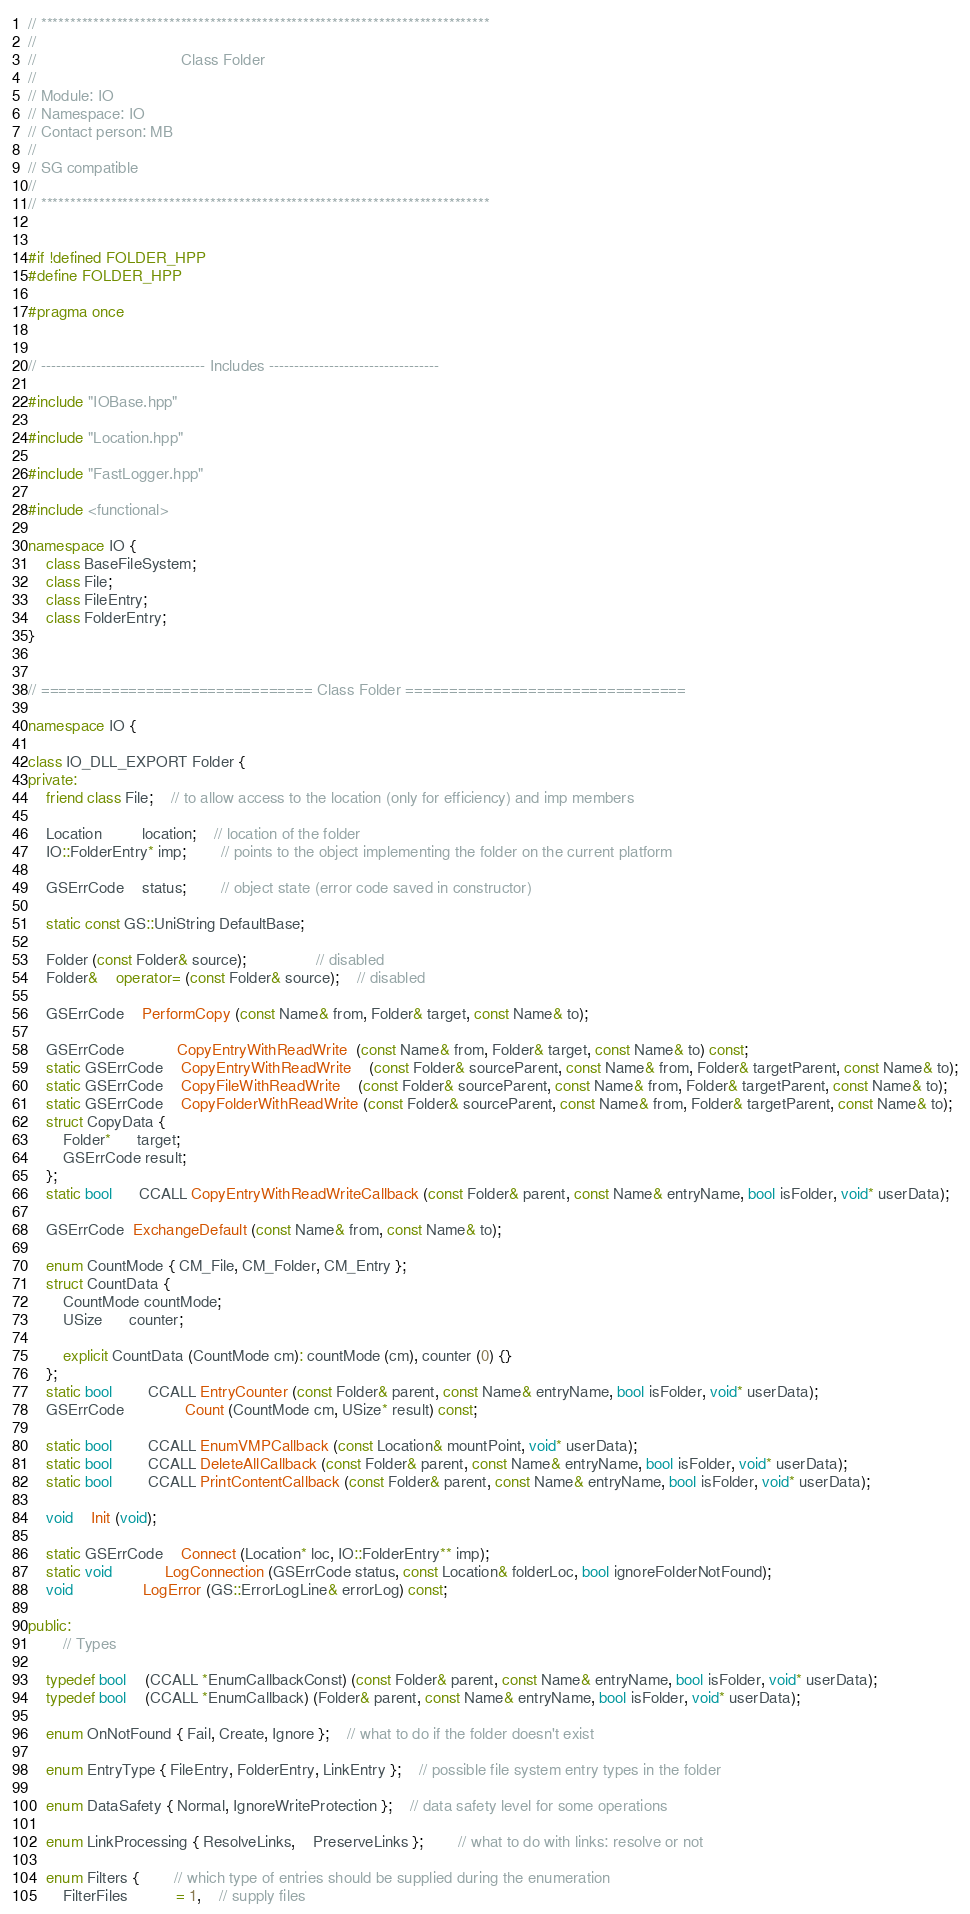Convert code to text. <code><loc_0><loc_0><loc_500><loc_500><_C++_>
// *****************************************************************************
//
//                                 Class Folder
//
// Module: IO
// Namespace: IO
// Contact person: MB
//
// SG compatible
//
// *****************************************************************************


#if !defined FOLDER_HPP
#define FOLDER_HPP

#pragma once


// --------------------------------- Includes ----------------------------------

#include "IOBase.hpp"

#include "Location.hpp"

#include "FastLogger.hpp"

#include <functional>

namespace IO {
	class BaseFileSystem;
	class File;
	class FileEntry;
	class FolderEntry;
}


// =============================== Class Folder ================================

namespace IO {

class IO_DLL_EXPORT Folder {
private:
	friend class File;	// to allow access to the location (only for efficiency) and imp members

	Location		 location;	// location of the folder
	IO::FolderEntry* imp;		// points to the object implementing the folder on the current platform

	GSErrCode	status;		// object state (error code saved in constructor)

	static const GS::UniString DefaultBase;

	Folder (const Folder& source);				// disabled
	Folder&	operator= (const Folder& source);	// disabled

	GSErrCode	PerformCopy (const Name& from, Folder& target, const Name& to);

	GSErrCode			CopyEntryWithReadWrite  (const Name& from, Folder& target, const Name& to) const;
	static GSErrCode	CopyEntryWithReadWrite	(const Folder& sourceParent, const Name& from, Folder& targetParent, const Name& to);
	static GSErrCode	CopyFileWithReadWrite	(const Folder& sourceParent, const Name& from, Folder& targetParent, const Name& to);
	static GSErrCode	CopyFolderWithReadWrite (const Folder& sourceParent, const Name& from, Folder& targetParent, const Name& to);
	struct CopyData {
		Folder*	  target;
		GSErrCode result;
	};
	static bool	  CCALL CopyEntryWithReadWriteCallback (const Folder& parent, const Name& entryName, bool isFolder, void* userData);

	GSErrCode  ExchangeDefault (const Name& from, const Name& to);

	enum CountMode { CM_File, CM_Folder, CM_Entry };
	struct CountData {
		CountMode countMode;
		USize	  counter;

		explicit CountData (CountMode cm): countMode (cm), counter (0) {}
	};
	static bool		CCALL EntryCounter (const Folder& parent, const Name& entryName, bool isFolder, void* userData);
	GSErrCode			  Count (CountMode cm, USize* result) const;

	static bool		CCALL EnumVMPCallback (const Location& mountPoint, void* userData);
	static bool		CCALL DeleteAllCallback (const Folder& parent, const Name& entryName, bool isFolder, void* userData);
	static bool		CCALL PrintContentCallback (const Folder& parent, const Name& entryName, bool isFolder, void* userData);

	void	Init (void);

	static GSErrCode	Connect (Location* loc, IO::FolderEntry** imp);
	static void			LogConnection (GSErrCode status, const Location& folderLoc, bool ignoreFolderNotFound);
	void				LogError (GS::ErrorLogLine& errorLog) const;

public:
		// Types

	typedef bool	(CCALL *EnumCallbackConst) (const Folder& parent, const Name& entryName, bool isFolder, void* userData);
	typedef bool	(CCALL *EnumCallback) (Folder& parent, const Name& entryName, bool isFolder, void* userData);

	enum OnNotFound { Fail, Create, Ignore };	// what to do if the folder doesn't exist

	enum EntryType { FileEntry, FolderEntry, LinkEntry };	// possible file system entry types in the folder

	enum DataSafety { Normal, IgnoreWriteProtection };	// data safety level for some operations

	enum LinkProcessing { ResolveLinks,	PreserveLinks };		// what to do with links: resolve or not

	enum Filters {		// which type of entries should be supplied during the enumeration
		FilterFiles		   = 1,	// supply files</code> 